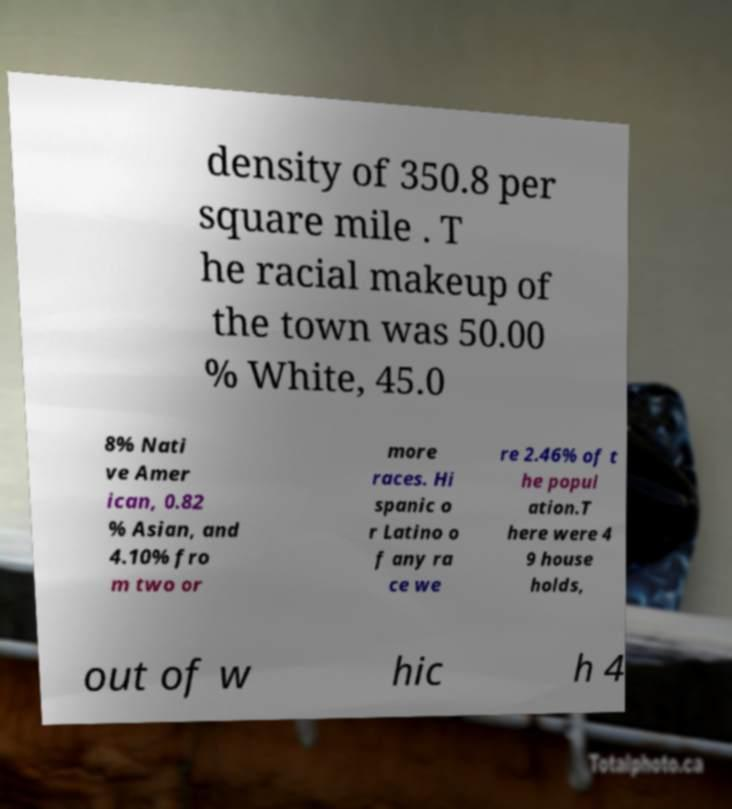Please read and relay the text visible in this image. What does it say? density of 350.8 per square mile . T he racial makeup of the town was 50.00 % White, 45.0 8% Nati ve Amer ican, 0.82 % Asian, and 4.10% fro m two or more races. Hi spanic o r Latino o f any ra ce we re 2.46% of t he popul ation.T here were 4 9 house holds, out of w hic h 4 